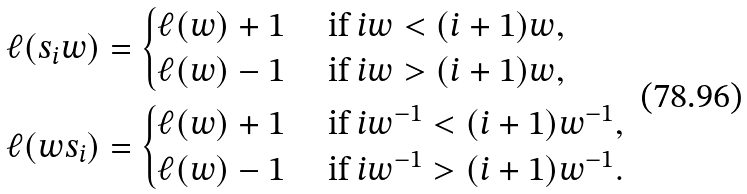<formula> <loc_0><loc_0><loc_500><loc_500>\ell ( s _ { i } w ) & = \begin{cases} \ell ( w ) + 1 & \text { if } i w < ( i + 1 ) w , \\ \ell ( w ) - 1 & \text { if } i w > ( i + 1 ) w , \end{cases} \\ \ell ( w s _ { i } ) & = \begin{cases} \ell ( w ) + 1 & \text { if } i w ^ { - 1 } < ( i + 1 ) w ^ { - 1 } , \\ \ell ( w ) - 1 & \text { if } i w ^ { - 1 } > ( i + 1 ) w ^ { - 1 } . \end{cases}</formula> 